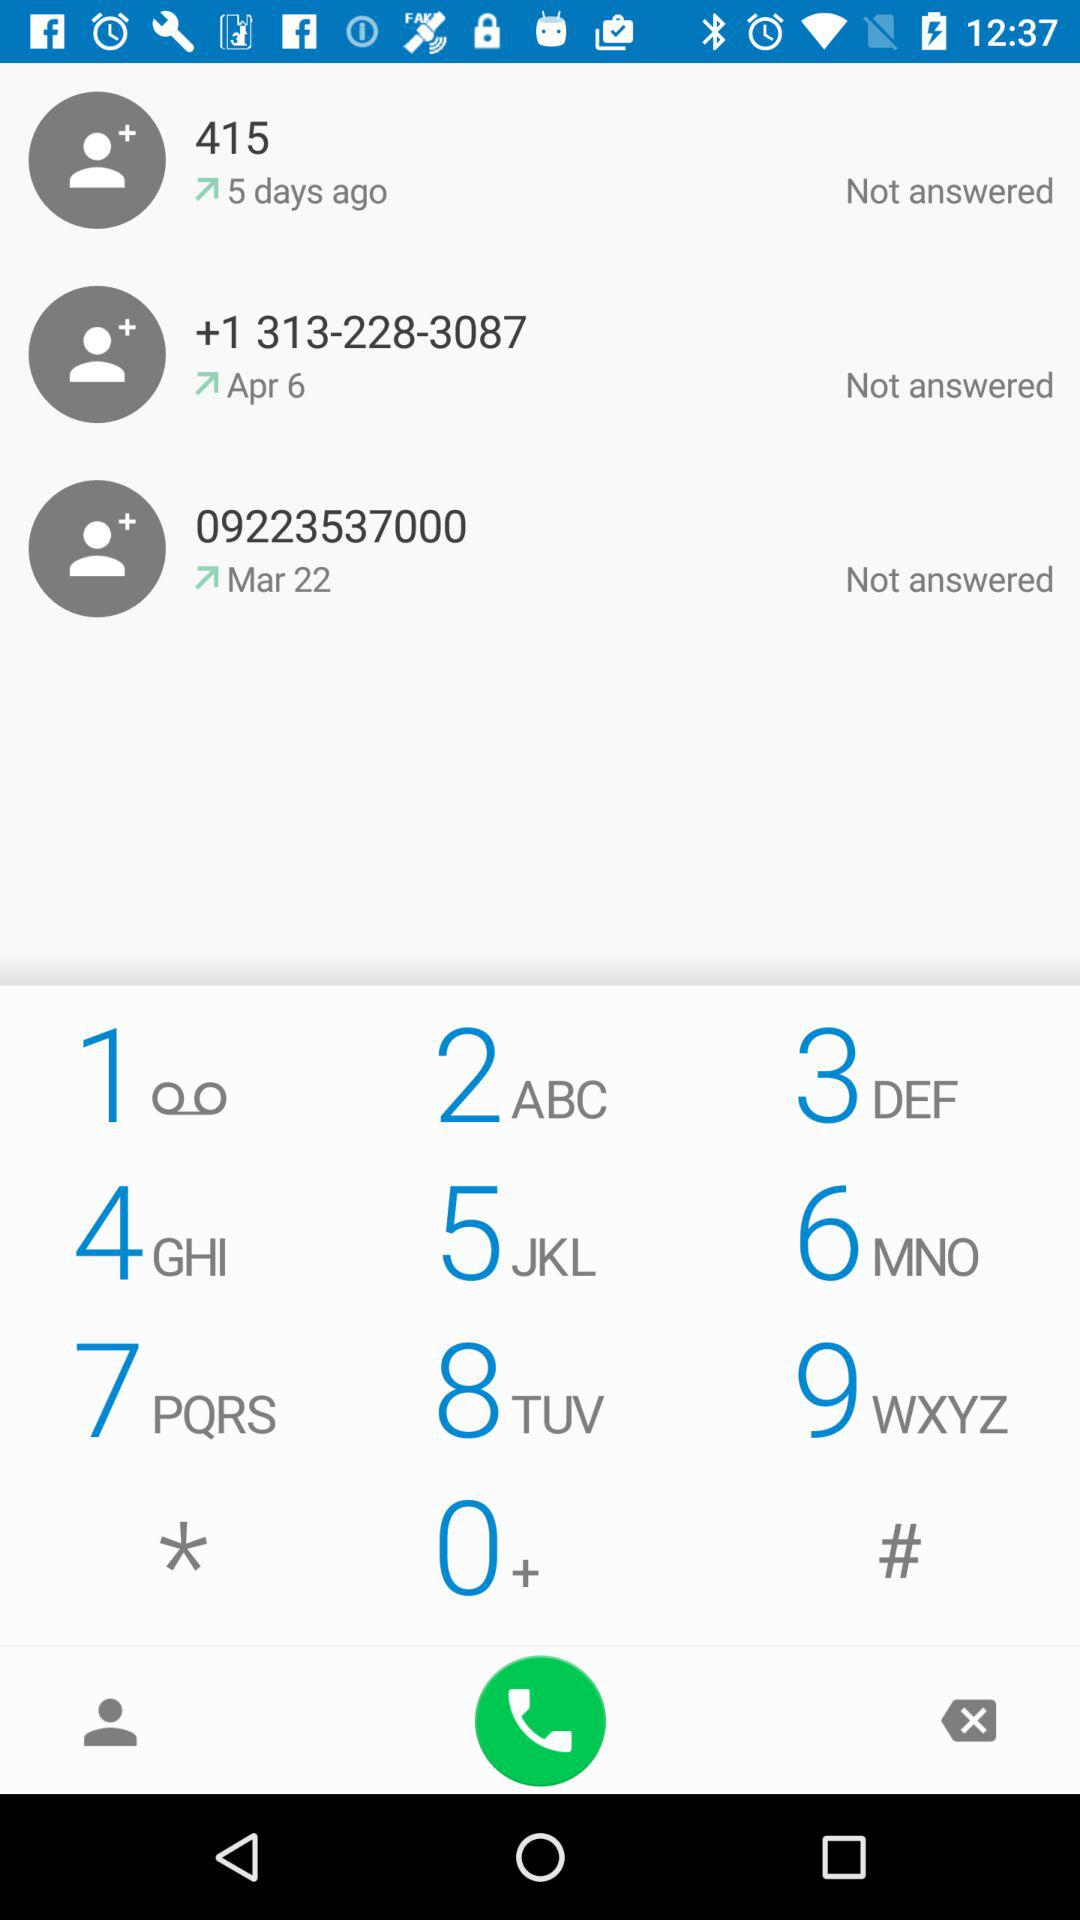Which number was dialed on April 5?
When the provided information is insufficient, respond with <no answer>. <no answer> 